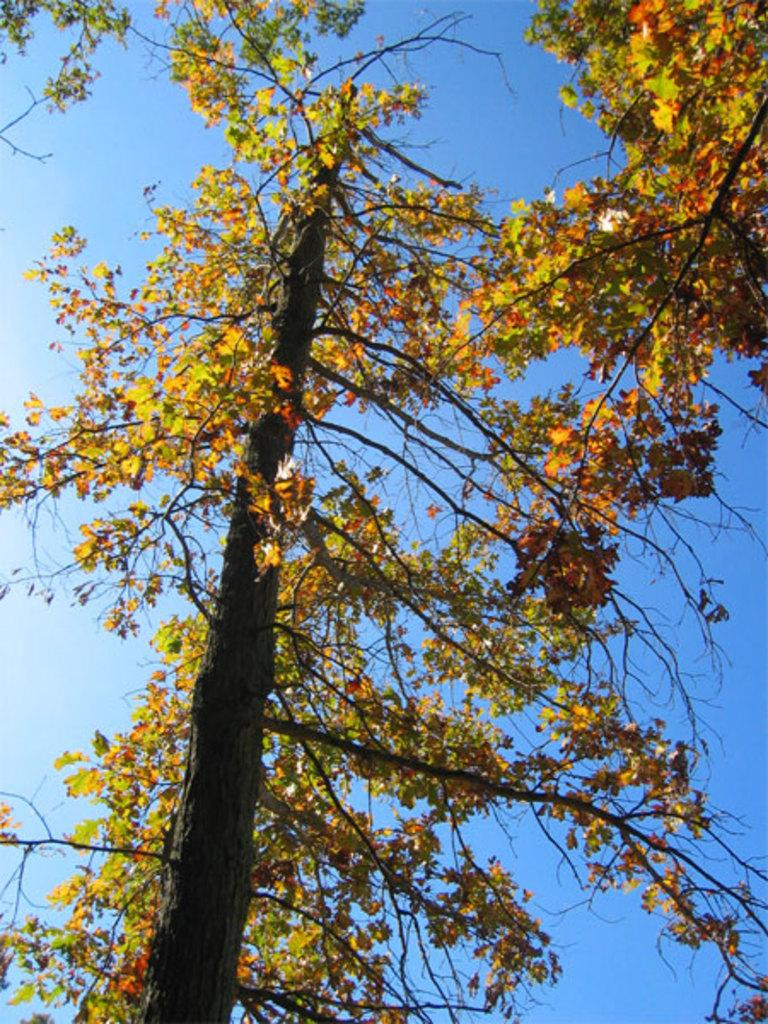What type of vegetation is present in the front of the image? There are trees in the front of the image. What part of the natural environment can be seen in the background of the image? The sky is visible in the background of the image. Where is the donkey standing in the image? There is no donkey present in the image. What type of curve can be seen in the sky in the image? The sky in the image is visible but does not show any curves. 